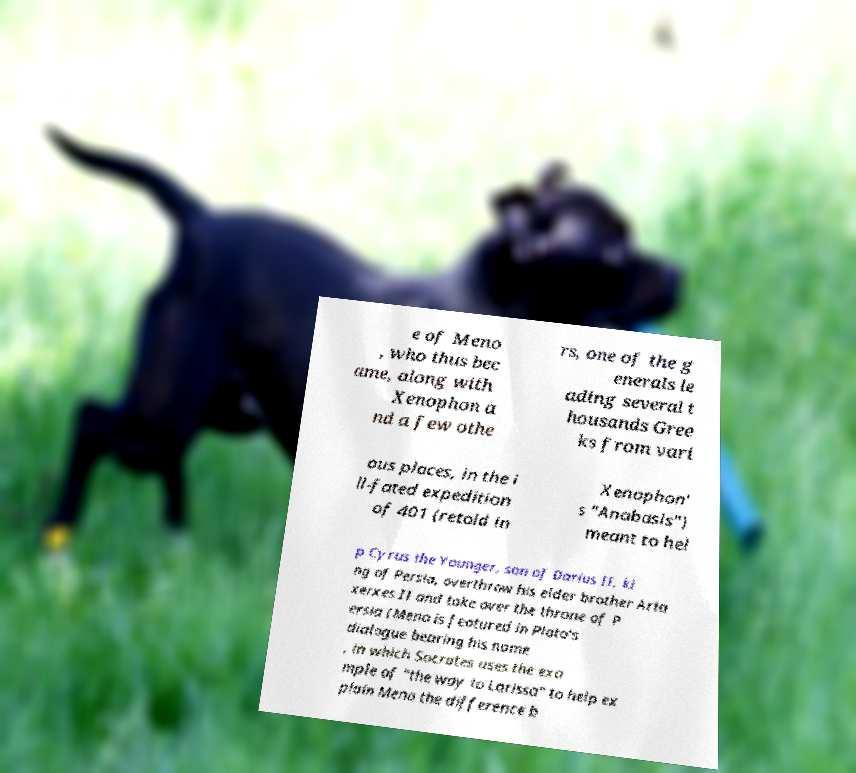Could you assist in decoding the text presented in this image and type it out clearly? e of Meno , who thus bec ame, along with Xenophon a nd a few othe rs, one of the g enerals le ading several t housands Gree ks from vari ous places, in the i ll-fated expedition of 401 (retold in Xenophon' s "Anabasis") meant to hel p Cyrus the Younger, son of Darius II, ki ng of Persia, overthrow his elder brother Arta xerxes II and take over the throne of P ersia (Meno is featured in Plato's dialogue bearing his name , in which Socrates uses the exa mple of "the way to Larissa" to help ex plain Meno the difference b 